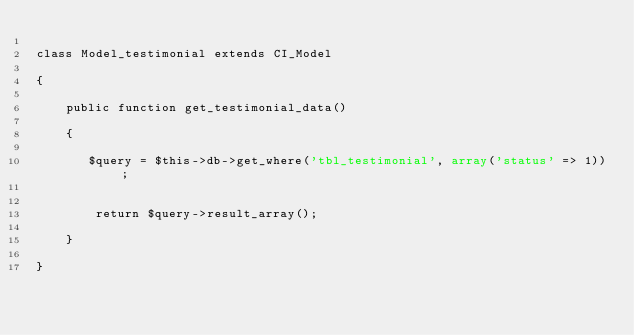Convert code to text. <code><loc_0><loc_0><loc_500><loc_500><_PHP_>
class Model_testimonial extends CI_Model 

{

    public function get_testimonial_data()

    {
       
       $query = $this->db->get_where('tbl_testimonial', array('status' => 1));
       

        return $query->result_array();

    }

}</code> 